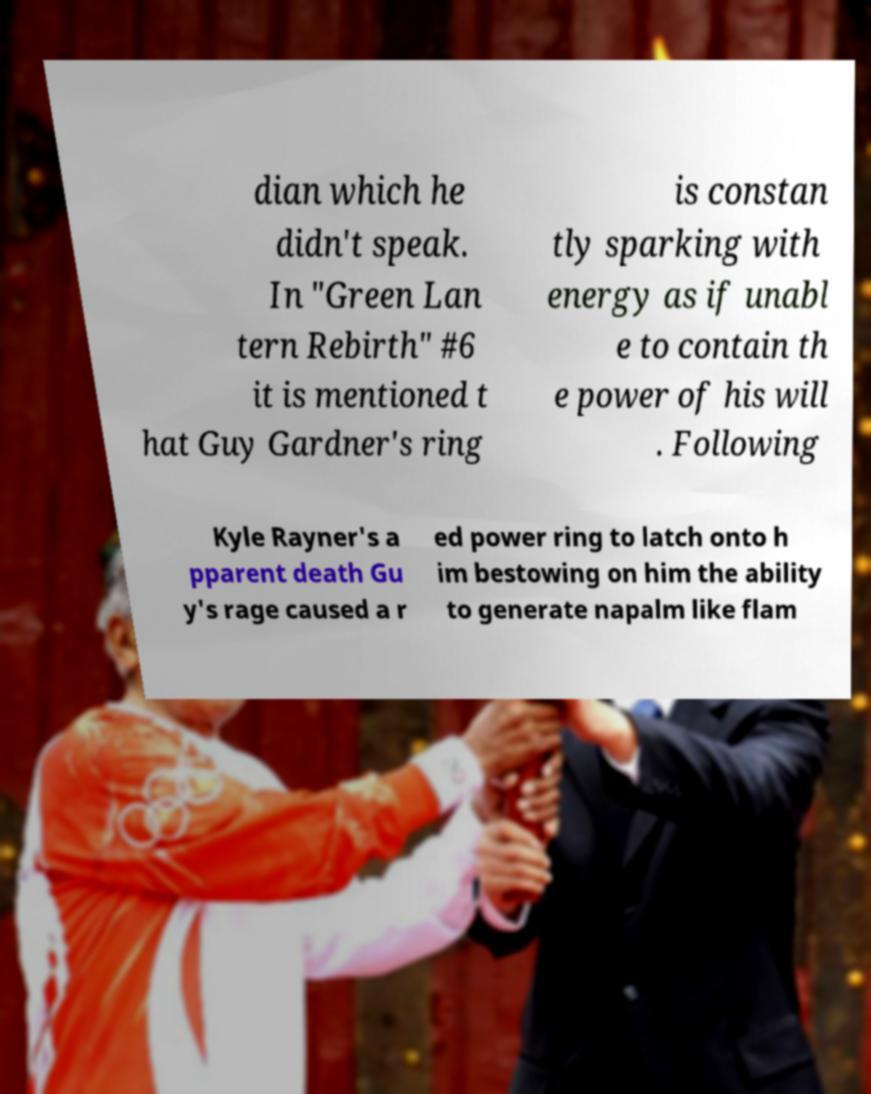I need the written content from this picture converted into text. Can you do that? dian which he didn't speak. In "Green Lan tern Rebirth" #6 it is mentioned t hat Guy Gardner's ring is constan tly sparking with energy as if unabl e to contain th e power of his will . Following Kyle Rayner's a pparent death Gu y's rage caused a r ed power ring to latch onto h im bestowing on him the ability to generate napalm like flam 